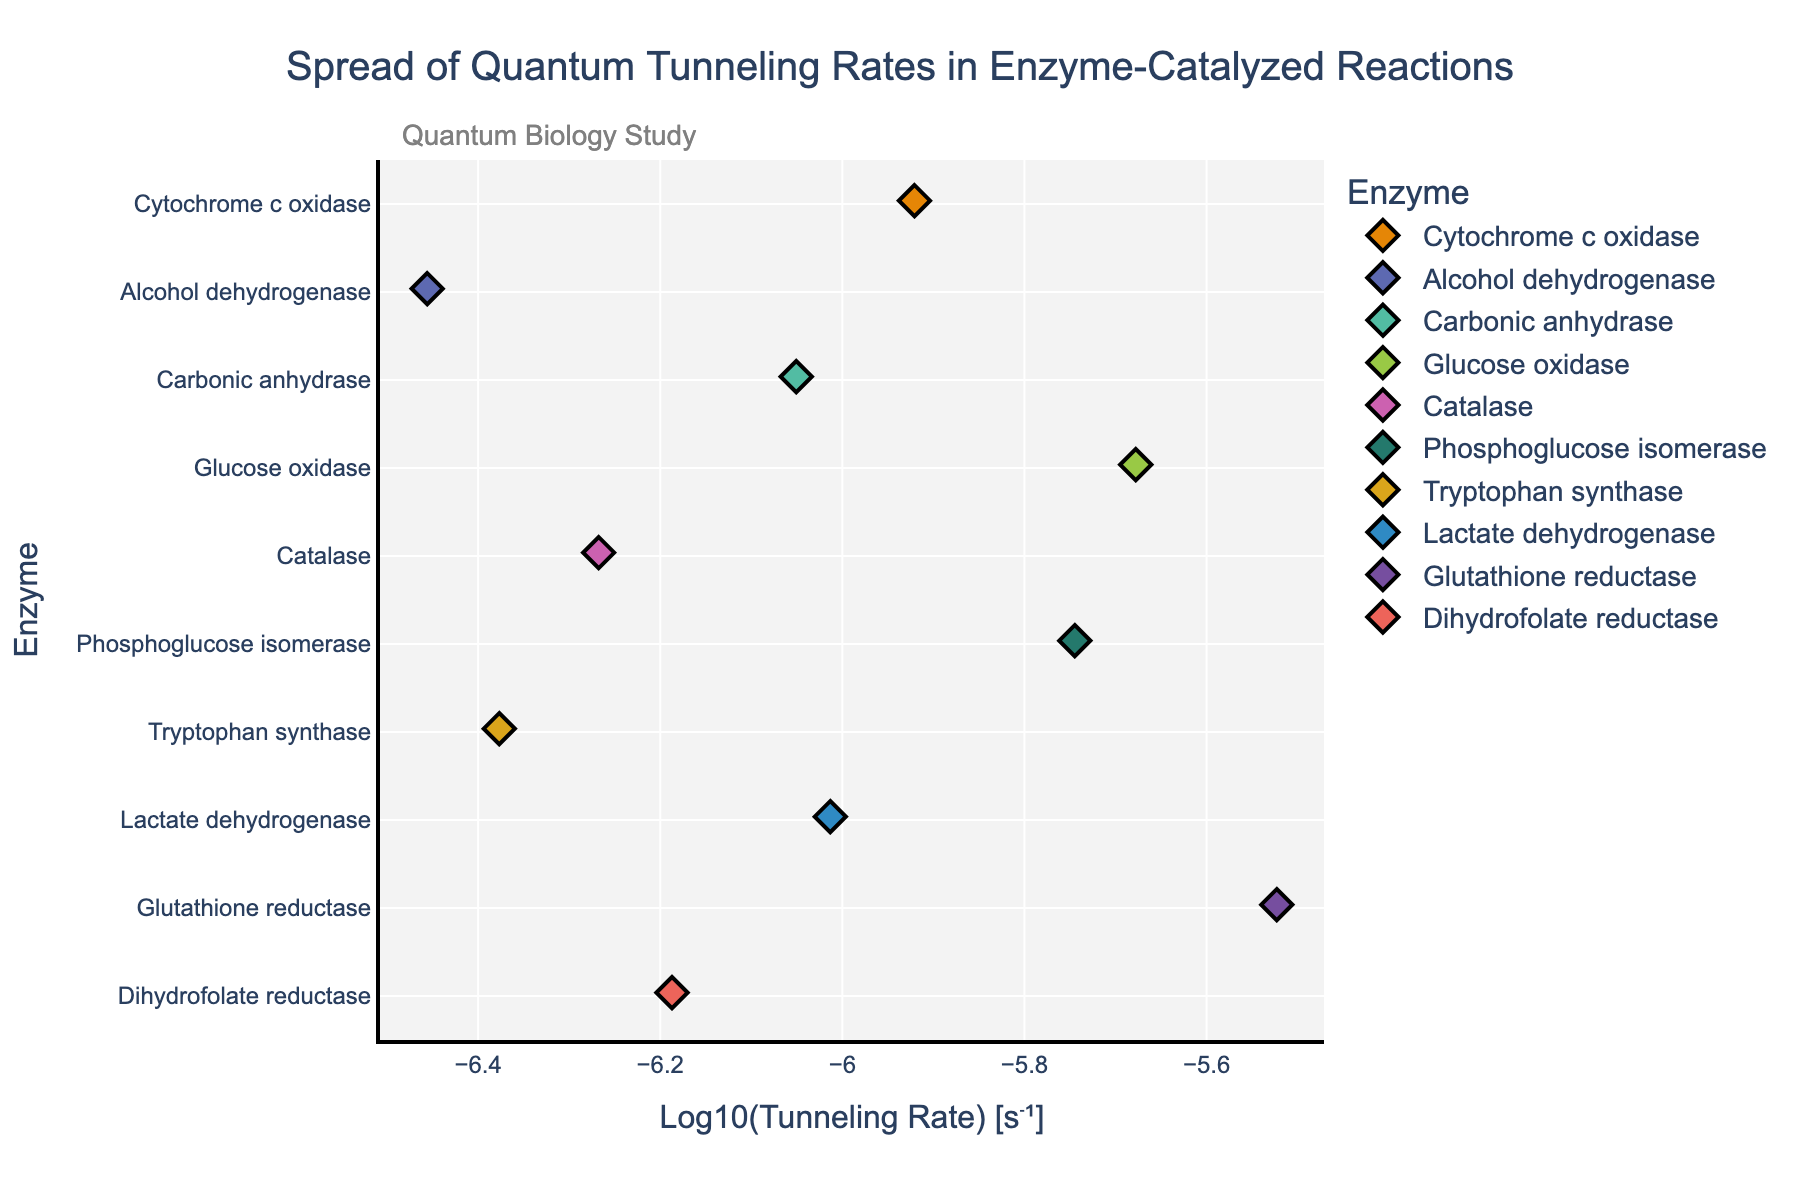What is the title of the figure? The title can be found at the top of the figure and provides an overview of what the figure is about. In this figure, the title is "Spread of Quantum Tunneling Rates in Enzyme-Catalyzed Reactions".
Answer: Spread of Quantum Tunneling Rates in Enzyme-Catalyzed Reactions What is the x-axis representing? The x-axis represents the logarithmic scale of the tunneling rates in units of seconds inverse, denoted as "Log10(Tunneling Rate) [s⁻¹]". This is indicated by the label on the x-axis.
Answer: Log10(Tunneling Rate) [s⁻¹] Which enzyme has the highest tunneling rate? The enzyme with the highest tunneling rate can be found by locating the rightmost data point on the x-axis. In this figure, the rightmost point corresponds to "Glutathione reductase".
Answer: Glutathione reductase Which enzyme has the lowest tunneling rate? The enzyme with the lowest tunneling rate is identified by the leftmost data point on the x-axis. This point corresponds to "Alcohol dehydrogenase".
Answer: Alcohol dehydrogenase How many enzymes are there in the figure? The number of enzymes can be counted by looking at the unique entries along the y-axis. Counting these entries gives a total of 10 enzymes.
Answer: 10 What is the approximate value of the tunneling rate for Cytochrome c oxidase on the log scale? The position of Cytochrome c oxidase on the x-axis indicates the logarithmic value of its tunneling rate. Cytochrome c oxidase is at approximately -5.92 on the log scale.
Answer: -5.92 Which enzyme has a tunneling rate closest to 1e-6 s⁻¹? To determine this, find the enzyme whose data point is closest to -6 on the log scale. "Cytochrome c oxidase" is closest to this value.
Answer: Cytochrome c oxidase What is the range of tunneling rates for the enzymes in the study? The range can be found by noting the difference between the highest and lowest values on the x-axis. The highest value is for "Glutathione reductase" at approximately -5.52 and the lowest is for "Alcohol dehydrogenase" at approximately -6.46. Subtracting these gives the range: -5.52 - (-6.46) = 0.94.
Answer: 0.94 Which enzyme cluster shows the greatest spread in tunneling rates? To determine this, observe clusters of data points for enzymes that appear spread out along the x-axis. "Glucose oxidase" shows a significant spread in tunneling rates.
Answer: Glucose oxidase 